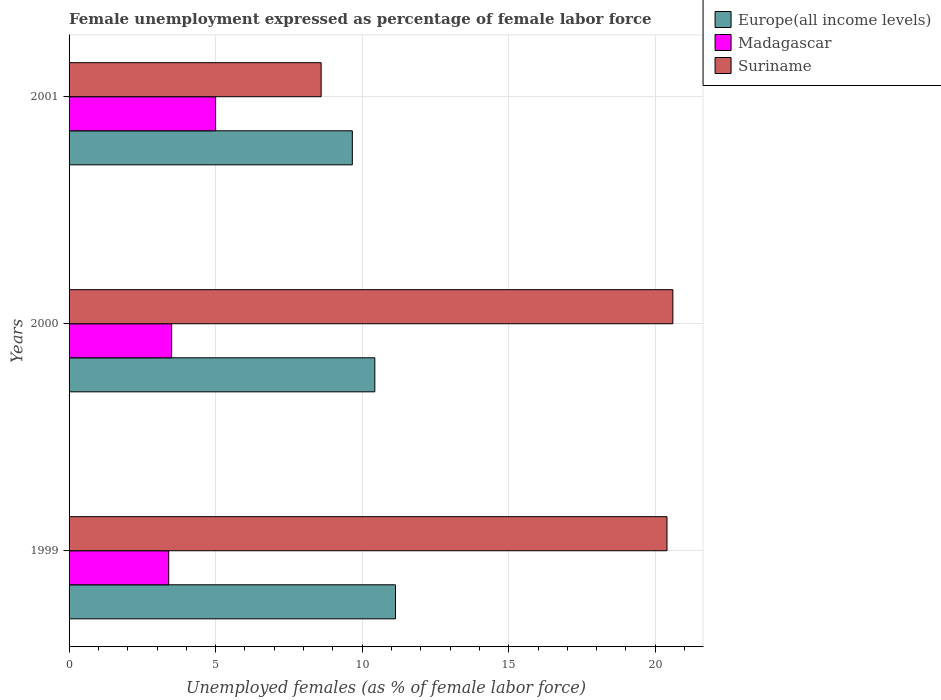How many different coloured bars are there?
Ensure brevity in your answer.  3. Are the number of bars per tick equal to the number of legend labels?
Your answer should be compact. Yes. How many bars are there on the 3rd tick from the top?
Your answer should be very brief. 3. In how many cases, is the number of bars for a given year not equal to the number of legend labels?
Ensure brevity in your answer.  0. What is the unemployment in females in in Suriname in 2000?
Provide a short and direct response. 20.6. Across all years, what is the maximum unemployment in females in in Europe(all income levels)?
Your answer should be very brief. 11.14. Across all years, what is the minimum unemployment in females in in Madagascar?
Keep it short and to the point. 3.4. What is the total unemployment in females in in Suriname in the graph?
Provide a short and direct response. 49.6. What is the difference between the unemployment in females in in Suriname in 1999 and that in 2001?
Make the answer very short. 11.8. What is the difference between the unemployment in females in in Madagascar in 2000 and the unemployment in females in in Europe(all income levels) in 2001?
Offer a very short reply. -6.16. What is the average unemployment in females in in Madagascar per year?
Your answer should be very brief. 3.97. In the year 2000, what is the difference between the unemployment in females in in Suriname and unemployment in females in in Madagascar?
Your response must be concise. 17.1. In how many years, is the unemployment in females in in Europe(all income levels) greater than 8 %?
Provide a succinct answer. 3. What is the ratio of the unemployment in females in in Madagascar in 1999 to that in 2000?
Make the answer very short. 0.97. Is the difference between the unemployment in females in in Suriname in 1999 and 2000 greater than the difference between the unemployment in females in in Madagascar in 1999 and 2000?
Keep it short and to the point. No. What is the difference between the highest and the second highest unemployment in females in in Europe(all income levels)?
Provide a short and direct response. 0.7. What is the difference between the highest and the lowest unemployment in females in in Europe(all income levels)?
Offer a terse response. 1.47. Is the sum of the unemployment in females in in Madagascar in 2000 and 2001 greater than the maximum unemployment in females in in Suriname across all years?
Your answer should be very brief. No. What does the 2nd bar from the top in 2000 represents?
Your response must be concise. Madagascar. What does the 2nd bar from the bottom in 1999 represents?
Provide a short and direct response. Madagascar. How many bars are there?
Your answer should be very brief. 9. How many years are there in the graph?
Your response must be concise. 3. What is the difference between two consecutive major ticks on the X-axis?
Keep it short and to the point. 5. Are the values on the major ticks of X-axis written in scientific E-notation?
Ensure brevity in your answer.  No. Does the graph contain any zero values?
Make the answer very short. No. Where does the legend appear in the graph?
Your answer should be compact. Top right. What is the title of the graph?
Offer a very short reply. Female unemployment expressed as percentage of female labor force. Does "Albania" appear as one of the legend labels in the graph?
Offer a very short reply. No. What is the label or title of the X-axis?
Make the answer very short. Unemployed females (as % of female labor force). What is the label or title of the Y-axis?
Give a very brief answer. Years. What is the Unemployed females (as % of female labor force) of Europe(all income levels) in 1999?
Ensure brevity in your answer.  11.14. What is the Unemployed females (as % of female labor force) of Madagascar in 1999?
Offer a very short reply. 3.4. What is the Unemployed females (as % of female labor force) of Suriname in 1999?
Give a very brief answer. 20.4. What is the Unemployed females (as % of female labor force) of Europe(all income levels) in 2000?
Offer a terse response. 10.43. What is the Unemployed females (as % of female labor force) of Suriname in 2000?
Ensure brevity in your answer.  20.6. What is the Unemployed females (as % of female labor force) in Europe(all income levels) in 2001?
Your response must be concise. 9.66. What is the Unemployed females (as % of female labor force) of Madagascar in 2001?
Keep it short and to the point. 5. What is the Unemployed females (as % of female labor force) in Suriname in 2001?
Make the answer very short. 8.6. Across all years, what is the maximum Unemployed females (as % of female labor force) in Europe(all income levels)?
Your response must be concise. 11.14. Across all years, what is the maximum Unemployed females (as % of female labor force) in Madagascar?
Offer a terse response. 5. Across all years, what is the maximum Unemployed females (as % of female labor force) in Suriname?
Your answer should be compact. 20.6. Across all years, what is the minimum Unemployed females (as % of female labor force) of Europe(all income levels)?
Your response must be concise. 9.66. Across all years, what is the minimum Unemployed females (as % of female labor force) of Madagascar?
Ensure brevity in your answer.  3.4. Across all years, what is the minimum Unemployed females (as % of female labor force) of Suriname?
Your answer should be compact. 8.6. What is the total Unemployed females (as % of female labor force) in Europe(all income levels) in the graph?
Provide a succinct answer. 31.23. What is the total Unemployed females (as % of female labor force) of Madagascar in the graph?
Make the answer very short. 11.9. What is the total Unemployed females (as % of female labor force) of Suriname in the graph?
Make the answer very short. 49.6. What is the difference between the Unemployed females (as % of female labor force) of Europe(all income levels) in 1999 and that in 2000?
Ensure brevity in your answer.  0.7. What is the difference between the Unemployed females (as % of female labor force) of Europe(all income levels) in 1999 and that in 2001?
Your answer should be compact. 1.47. What is the difference between the Unemployed females (as % of female labor force) of Europe(all income levels) in 2000 and that in 2001?
Give a very brief answer. 0.77. What is the difference between the Unemployed females (as % of female labor force) in Madagascar in 2000 and that in 2001?
Your answer should be very brief. -1.5. What is the difference between the Unemployed females (as % of female labor force) of Europe(all income levels) in 1999 and the Unemployed females (as % of female labor force) of Madagascar in 2000?
Offer a very short reply. 7.64. What is the difference between the Unemployed females (as % of female labor force) of Europe(all income levels) in 1999 and the Unemployed females (as % of female labor force) of Suriname in 2000?
Make the answer very short. -9.46. What is the difference between the Unemployed females (as % of female labor force) of Madagascar in 1999 and the Unemployed females (as % of female labor force) of Suriname in 2000?
Your answer should be compact. -17.2. What is the difference between the Unemployed females (as % of female labor force) in Europe(all income levels) in 1999 and the Unemployed females (as % of female labor force) in Madagascar in 2001?
Make the answer very short. 6.14. What is the difference between the Unemployed females (as % of female labor force) in Europe(all income levels) in 1999 and the Unemployed females (as % of female labor force) in Suriname in 2001?
Your answer should be very brief. 2.54. What is the difference between the Unemployed females (as % of female labor force) of Madagascar in 1999 and the Unemployed females (as % of female labor force) of Suriname in 2001?
Provide a succinct answer. -5.2. What is the difference between the Unemployed females (as % of female labor force) of Europe(all income levels) in 2000 and the Unemployed females (as % of female labor force) of Madagascar in 2001?
Give a very brief answer. 5.43. What is the difference between the Unemployed females (as % of female labor force) of Europe(all income levels) in 2000 and the Unemployed females (as % of female labor force) of Suriname in 2001?
Provide a succinct answer. 1.83. What is the difference between the Unemployed females (as % of female labor force) in Madagascar in 2000 and the Unemployed females (as % of female labor force) in Suriname in 2001?
Offer a terse response. -5.1. What is the average Unemployed females (as % of female labor force) in Europe(all income levels) per year?
Keep it short and to the point. 10.41. What is the average Unemployed females (as % of female labor force) in Madagascar per year?
Offer a very short reply. 3.97. What is the average Unemployed females (as % of female labor force) of Suriname per year?
Provide a succinct answer. 16.53. In the year 1999, what is the difference between the Unemployed females (as % of female labor force) in Europe(all income levels) and Unemployed females (as % of female labor force) in Madagascar?
Ensure brevity in your answer.  7.74. In the year 1999, what is the difference between the Unemployed females (as % of female labor force) in Europe(all income levels) and Unemployed females (as % of female labor force) in Suriname?
Give a very brief answer. -9.26. In the year 2000, what is the difference between the Unemployed females (as % of female labor force) in Europe(all income levels) and Unemployed females (as % of female labor force) in Madagascar?
Your answer should be compact. 6.93. In the year 2000, what is the difference between the Unemployed females (as % of female labor force) in Europe(all income levels) and Unemployed females (as % of female labor force) in Suriname?
Provide a succinct answer. -10.17. In the year 2000, what is the difference between the Unemployed females (as % of female labor force) in Madagascar and Unemployed females (as % of female labor force) in Suriname?
Your response must be concise. -17.1. In the year 2001, what is the difference between the Unemployed females (as % of female labor force) in Europe(all income levels) and Unemployed females (as % of female labor force) in Madagascar?
Offer a terse response. 4.66. In the year 2001, what is the difference between the Unemployed females (as % of female labor force) in Europe(all income levels) and Unemployed females (as % of female labor force) in Suriname?
Provide a succinct answer. 1.06. In the year 2001, what is the difference between the Unemployed females (as % of female labor force) of Madagascar and Unemployed females (as % of female labor force) of Suriname?
Offer a very short reply. -3.6. What is the ratio of the Unemployed females (as % of female labor force) in Europe(all income levels) in 1999 to that in 2000?
Offer a terse response. 1.07. What is the ratio of the Unemployed females (as % of female labor force) of Madagascar in 1999 to that in 2000?
Give a very brief answer. 0.97. What is the ratio of the Unemployed females (as % of female labor force) of Suriname in 1999 to that in 2000?
Provide a short and direct response. 0.99. What is the ratio of the Unemployed females (as % of female labor force) of Europe(all income levels) in 1999 to that in 2001?
Keep it short and to the point. 1.15. What is the ratio of the Unemployed females (as % of female labor force) of Madagascar in 1999 to that in 2001?
Provide a short and direct response. 0.68. What is the ratio of the Unemployed females (as % of female labor force) in Suriname in 1999 to that in 2001?
Offer a terse response. 2.37. What is the ratio of the Unemployed females (as % of female labor force) in Europe(all income levels) in 2000 to that in 2001?
Offer a very short reply. 1.08. What is the ratio of the Unemployed females (as % of female labor force) of Madagascar in 2000 to that in 2001?
Offer a terse response. 0.7. What is the ratio of the Unemployed females (as % of female labor force) of Suriname in 2000 to that in 2001?
Keep it short and to the point. 2.4. What is the difference between the highest and the second highest Unemployed females (as % of female labor force) in Europe(all income levels)?
Provide a succinct answer. 0.7. What is the difference between the highest and the lowest Unemployed females (as % of female labor force) of Europe(all income levels)?
Your answer should be very brief. 1.47. What is the difference between the highest and the lowest Unemployed females (as % of female labor force) of Madagascar?
Provide a short and direct response. 1.6. What is the difference between the highest and the lowest Unemployed females (as % of female labor force) in Suriname?
Give a very brief answer. 12. 